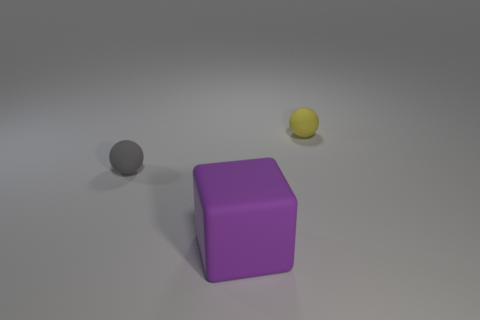Add 3 gray things. How many objects exist? 6 Subtract all balls. How many objects are left? 1 Add 3 small yellow matte spheres. How many small yellow matte spheres exist? 4 Subtract 0 brown cubes. How many objects are left? 3 Subtract all purple blocks. Subtract all gray matte things. How many objects are left? 1 Add 3 matte blocks. How many matte blocks are left? 4 